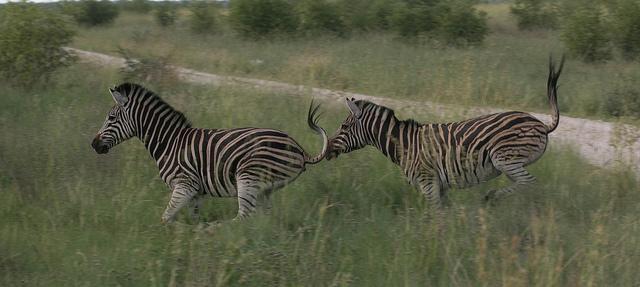How many zebras are visible?
Give a very brief answer. 2. How many people are under the tent?
Give a very brief answer. 0. 